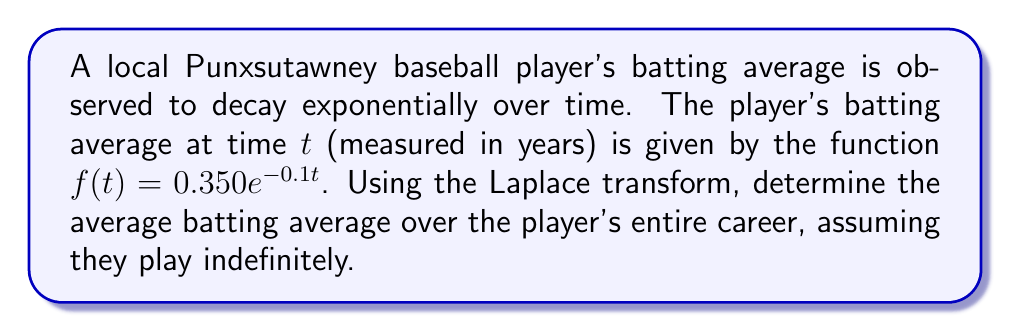Solve this math problem. To solve this problem, we'll use the Laplace transform and its properties. Let's break it down step-by-step:

1) The Laplace transform of $f(t)$ is defined as:

   $$F(s) = \mathcal{L}\{f(t)\} = \int_0^\infty f(t)e^{-st}dt$$

2) In this case, $f(t) = 0.350e^{-0.1t}$, so we need to calculate:

   $$F(s) = \int_0^\infty 0.350e^{-0.1t}e^{-st}dt = 0.350\int_0^\infty e^{-(s+0.1)t}dt$$

3) Using the property of the Laplace transform of exponential functions:

   $$\mathcal{L}\{e^{-at}\} = \frac{1}{s+a}$$

4) We can write:

   $$F(s) = 0.350 \cdot \frac{1}{s+0.1}$$

5) The average value of a function over an infinite interval is given by:

   $$\lim_{s \to 0} sF(s)$$

6) Applying this to our function:

   $$\lim_{s \to 0} s \cdot 0.350 \cdot \frac{1}{s+0.1} = 0.350 \cdot \lim_{s \to 0} \frac{s}{s+0.1}$$

7) Evaluating the limit:

   $$0.350 \cdot \frac{0}{0+0.1} = 0.350 \cdot 0 = 0$$

This result indicates that over an infinite career, the player's average batting average approaches zero, which makes sense given the exponential decay.

However, for a more practical interpretation, we might consider the average over a finite career, say 20 years:

8) The average over a finite interval $[0,T]$ is given by:

   $$\frac{1}{T}\int_0^T f(t)dt = \frac{1}{T} \cdot 0.350 \cdot \frac{1-e^{-0.1T}}{0.1}$$

9) For $T = 20$ years:

   $$\frac{1}{20} \cdot 0.350 \cdot \frac{1-e^{-0.1 \cdot 20}}{0.1} \approx 0.1655$$
Answer: The average batting average over the player's entire (infinite) career approaches 0. For a more practical 20-year career, the average batting average is approximately 0.1655. 